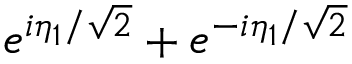Convert formula to latex. <formula><loc_0><loc_0><loc_500><loc_500>e ^ { i \eta _ { 1 } / \sqrt { 2 } } + e ^ { - i \eta _ { 1 } / \sqrt { 2 } }</formula> 